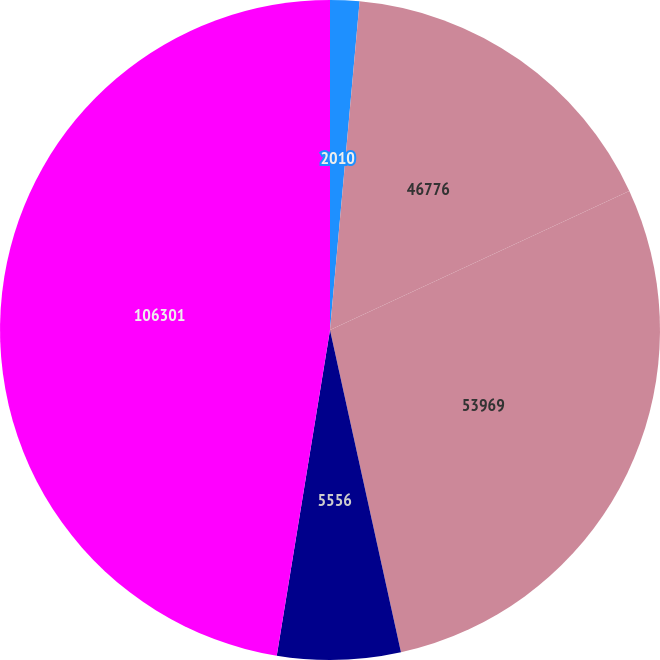<chart> <loc_0><loc_0><loc_500><loc_500><pie_chart><fcel>2010<fcel>46776<fcel>53969<fcel>5556<fcel>106301<nl><fcel>1.43%<fcel>16.65%<fcel>28.47%<fcel>6.03%<fcel>47.42%<nl></chart> 